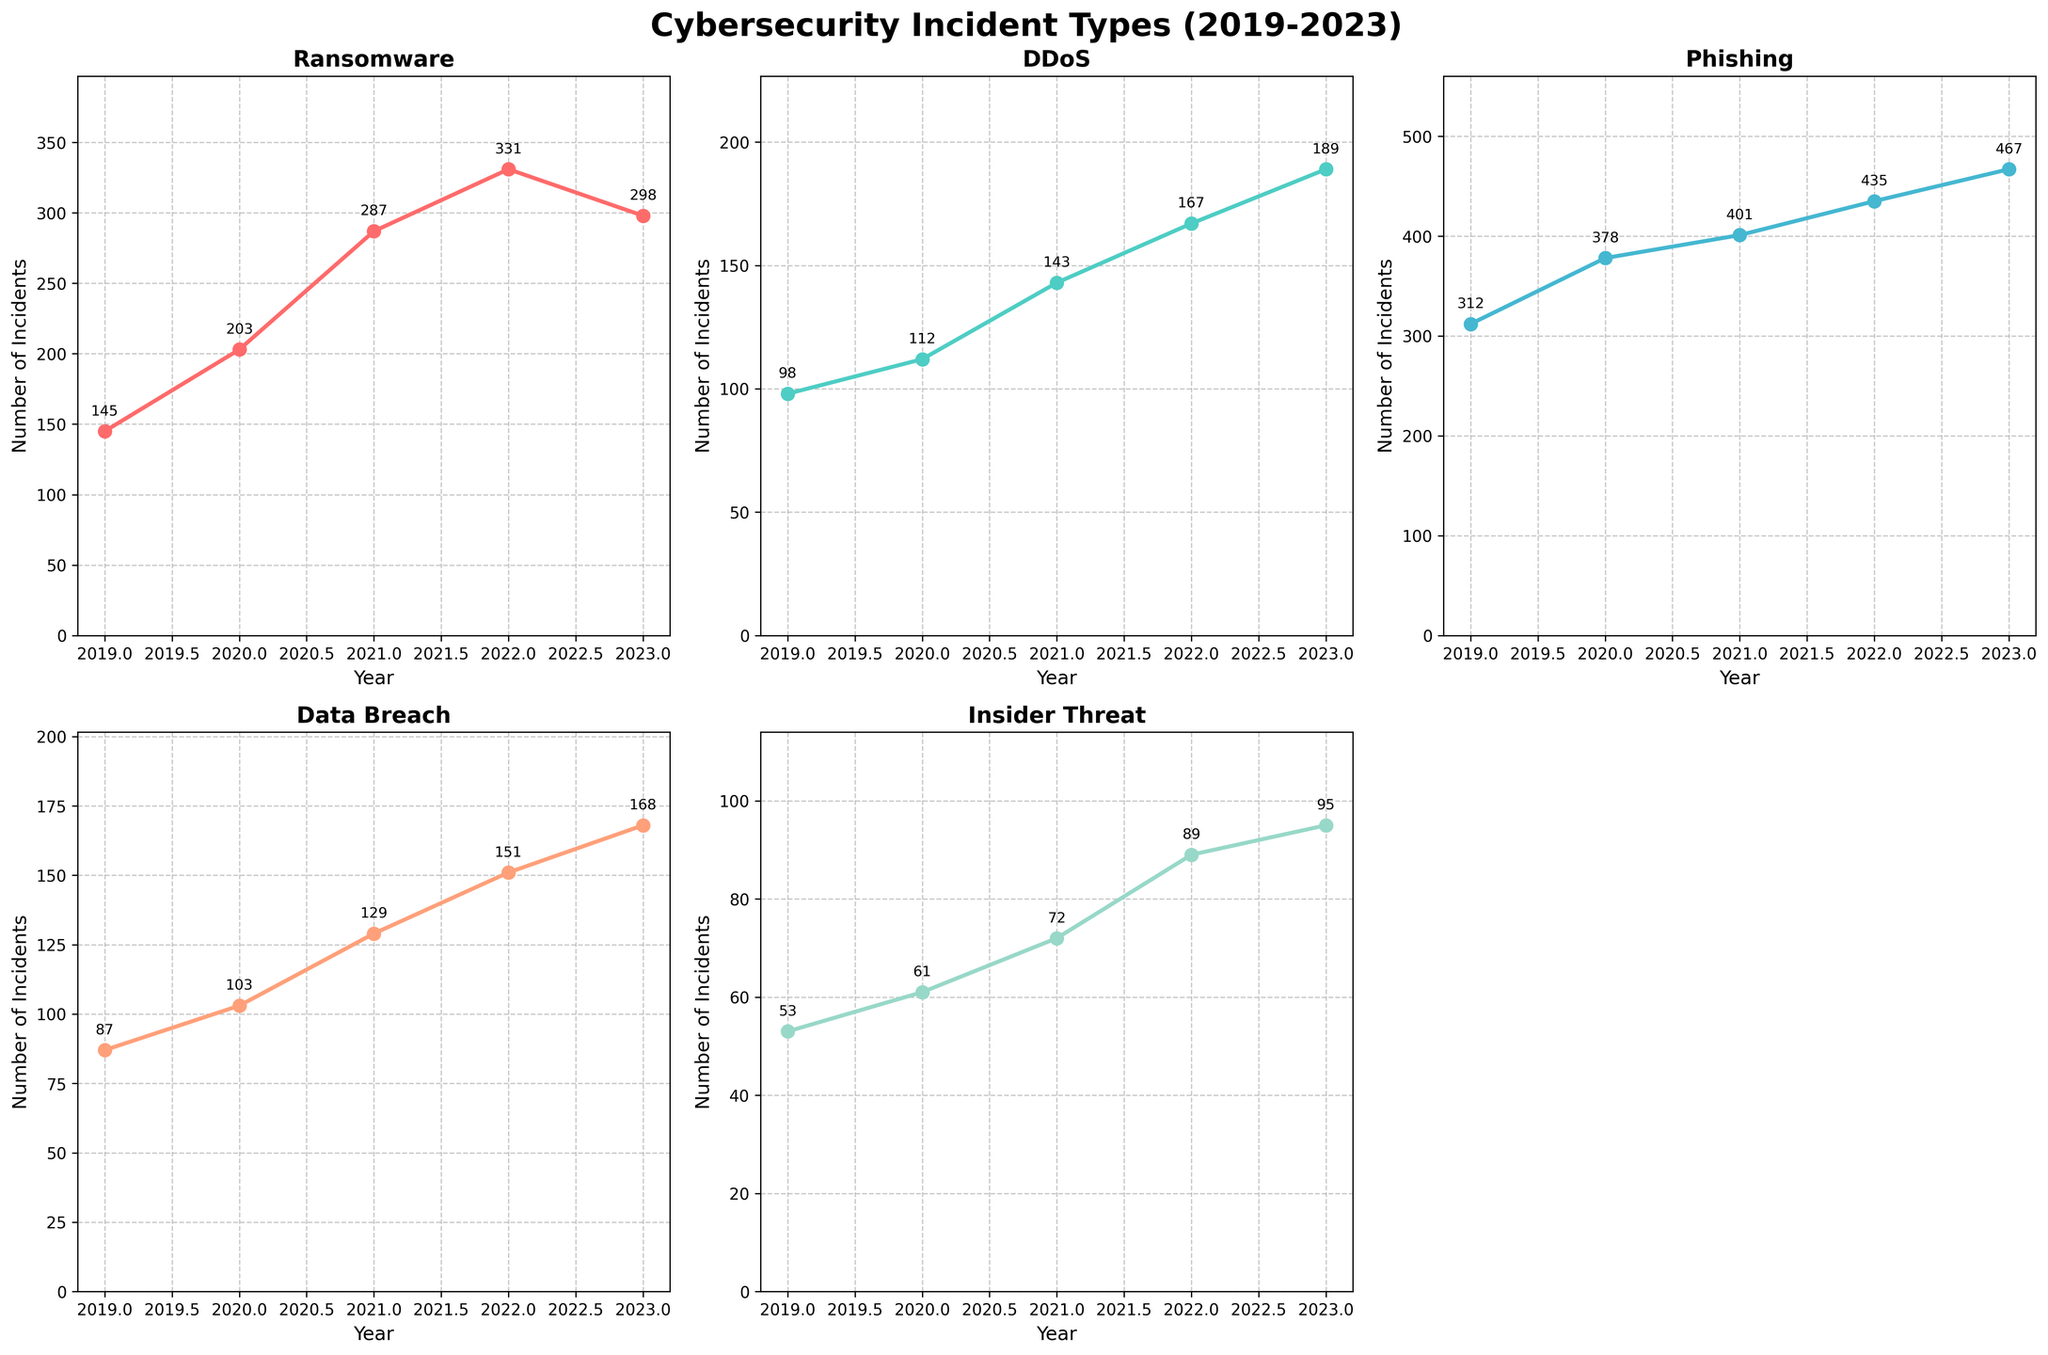How many major types of cybersecurity incidents are analyzed in this figure? The figure contains 5 subplots, each representing a different type of cybersecurity incident: Ransomware, DDoS, Phishing, Data Breach, and Insider Threat.
Answer: 5 Which type of incident saw the largest increase in frequency from 2019 to 2023? By looking at the trends in each subplot, the Phishing incidents increased from 312 in 2019 to 467 in 2023, which is the largest numerical increase compared to other incident types.
Answer: Phishing What is the total number of Data Breach incidents over the 5-year span? Adding the number of Data Breach incidents from each year: 87 (2019) + 103 (2020) + 129 (2021) + 151 (2022) + 168 (2023) = 638
Answer: 638 In which year did DDoS incidents first exceed 150? Observing the subplot for DDoS, the incidents first exceed 150 in 2022 with 167 incidents.
Answer: 2022 Between 2022 and 2023, which incident type had the smallest increase in frequency? The increase for each type is calculated as follows:
- Ransomware (2022: 331, 2023: 298) = Decrease by 33
- DDoS (2022: 167, 2023: 189) = 22
- Phishing (2022: 435, 2023: 467) = 32
- Data Breach (2022: 151, 2023: 168) = 17
- Insider Threat (2022: 89, 2023: 95) = 6
So, Insider Threat had the smallest increase of 6.
Answer: Insider Threat Which incident type shows the most consistent upward trend over the past 5 years? By visual inspection, Phishing incidents consistently increase every year from 2019 to 2023 without any decline.
Answer: Phishing What is the average frequency of Ransomware incidents per year over this period? The average is calculated by summing Ransomware incidents for each year and dividing by the number of years: (145 + 203 + 287 + 331 + 298) / 5 = 252.8
Answer: 252.8 Did any incident types decrease in frequency from 2022 to 2023? Observing the line plots, the subplots for Ransomware show a decrease from 331 in 2022 to 298 in 2023.
Answer: Yes, Ransomware What was the frequency difference between Data Breach and Insider Threat incidents in 2023? Data Breach had 168 incidents in 2023, whereas Insider Threat had 95 incidents. The difference is 168 - 95 = 73.
Answer: 73 